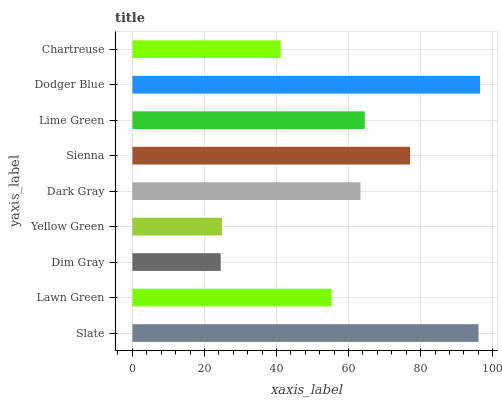Is Dim Gray the minimum?
Answer yes or no. Yes. Is Dodger Blue the maximum?
Answer yes or no. Yes. Is Lawn Green the minimum?
Answer yes or no. No. Is Lawn Green the maximum?
Answer yes or no. No. Is Slate greater than Lawn Green?
Answer yes or no. Yes. Is Lawn Green less than Slate?
Answer yes or no. Yes. Is Lawn Green greater than Slate?
Answer yes or no. No. Is Slate less than Lawn Green?
Answer yes or no. No. Is Dark Gray the high median?
Answer yes or no. Yes. Is Dark Gray the low median?
Answer yes or no. Yes. Is Chartreuse the high median?
Answer yes or no. No. Is Yellow Green the low median?
Answer yes or no. No. 